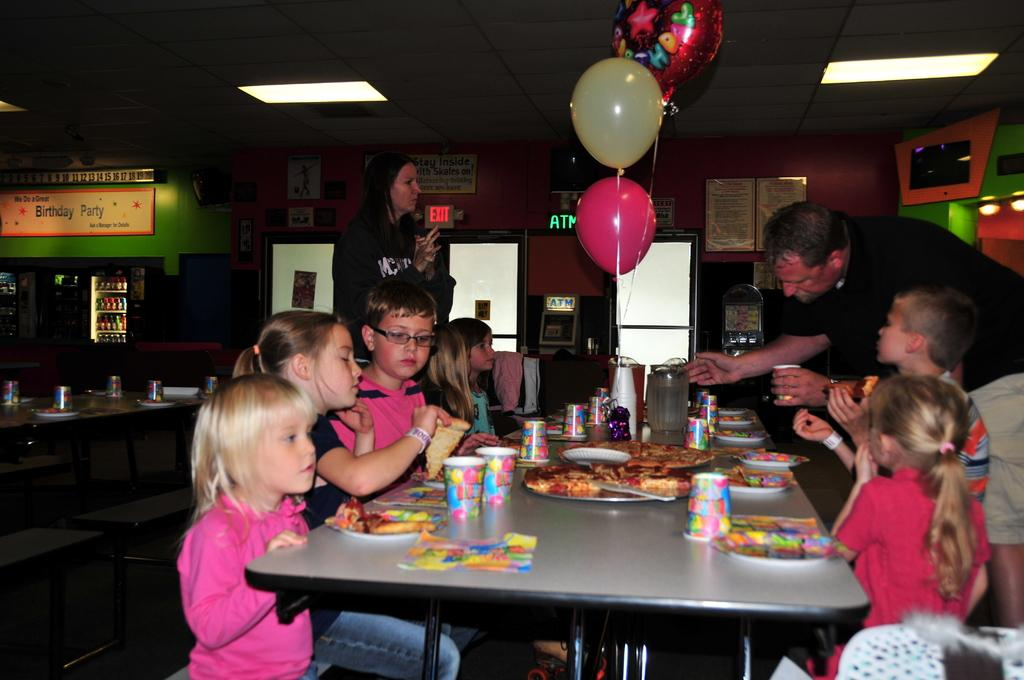Who is present in the image? There is a couple in the image. What are the couple doing in the image? The couple is arranging food items in the image. Who are the food items intended for? The food items are for children. What type of event is taking place in the image? The event is a birthday party. What time is displayed on the clock in the image? There is no clock present in the image. Can you describe the volleyball game taking place in the background of the image? There is no volleyball game present in the image; it focuses on the couple arranging food items for a birthday party. 